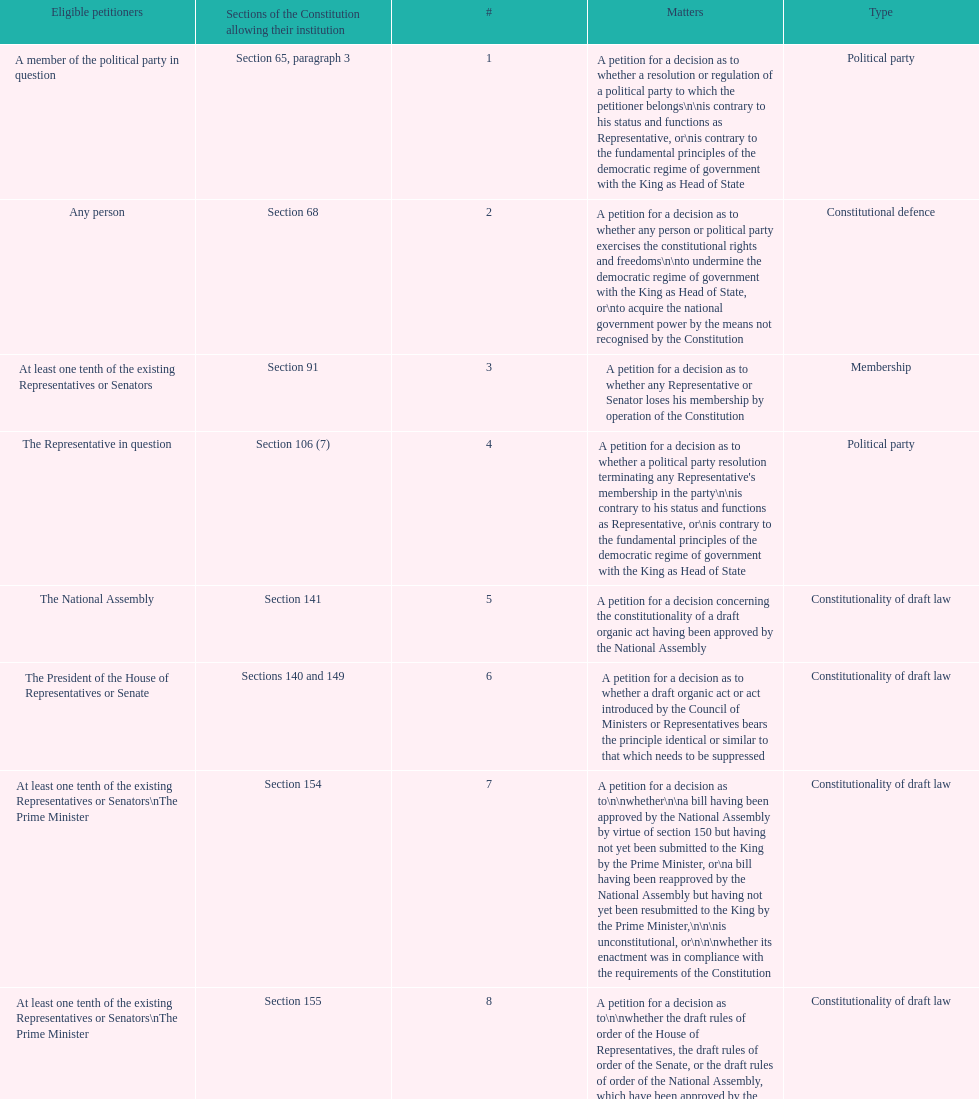How many matters require at least one tenth of the existing representatives or senators? 7. 